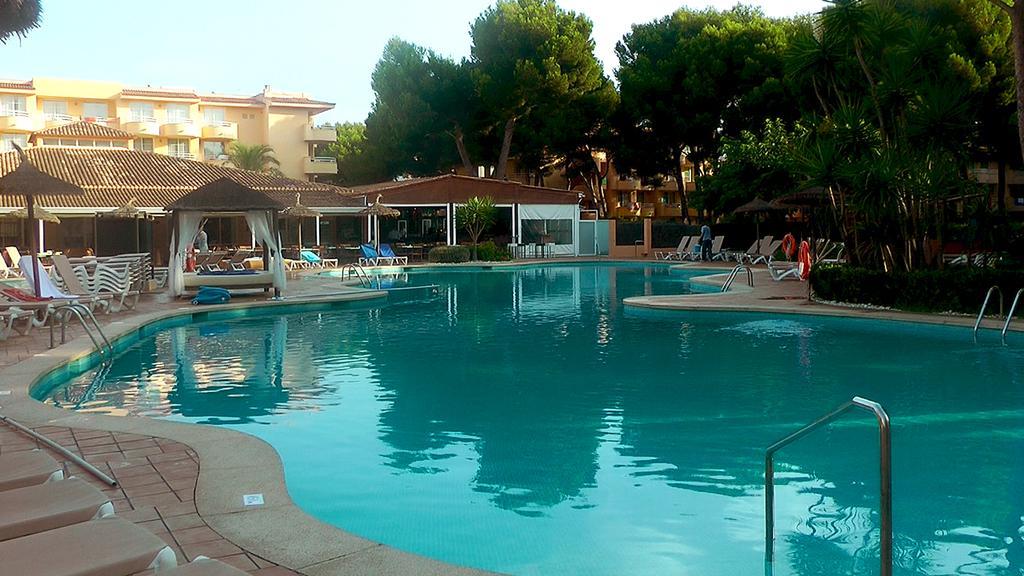Describe this image in one or two sentences. In this image we can see a swimming pool, handrails, chairs, umbrella, bed, plants, trees, sheds, buildings, and people. In the background there is sky. 